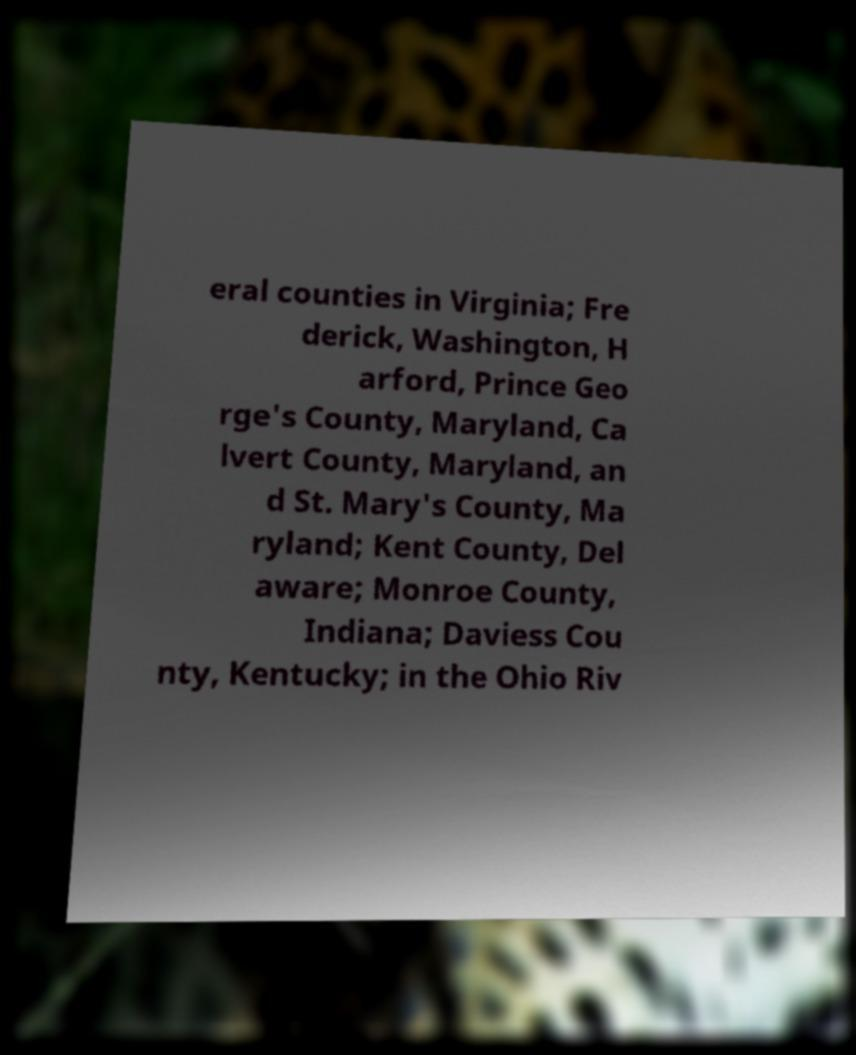Could you assist in decoding the text presented in this image and type it out clearly? eral counties in Virginia; Fre derick, Washington, H arford, Prince Geo rge's County, Maryland, Ca lvert County, Maryland, an d St. Mary's County, Ma ryland; Kent County, Del aware; Monroe County, Indiana; Daviess Cou nty, Kentucky; in the Ohio Riv 